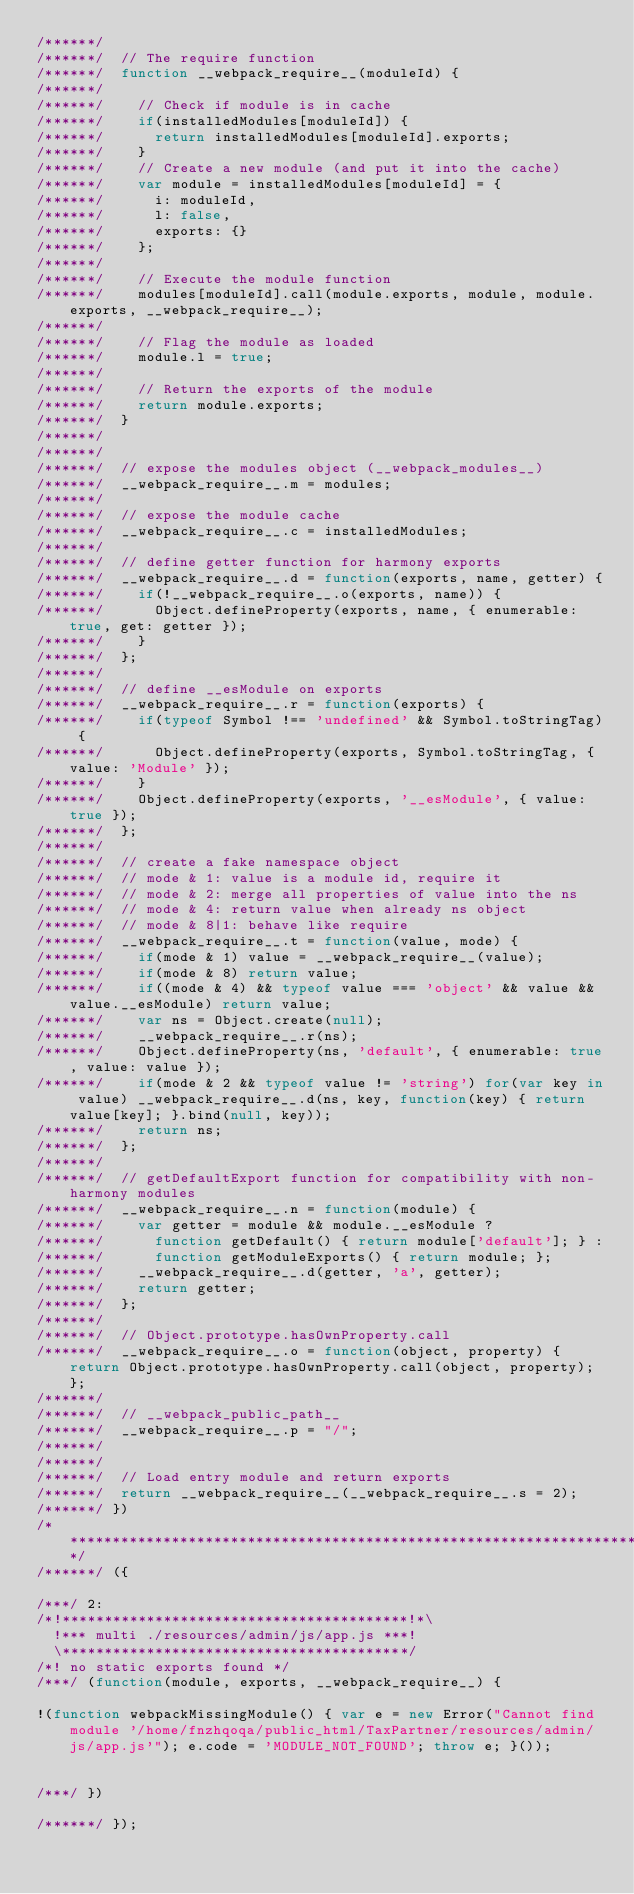<code> <loc_0><loc_0><loc_500><loc_500><_JavaScript_>/******/
/******/ 	// The require function
/******/ 	function __webpack_require__(moduleId) {
/******/
/******/ 		// Check if module is in cache
/******/ 		if(installedModules[moduleId]) {
/******/ 			return installedModules[moduleId].exports;
/******/ 		}
/******/ 		// Create a new module (and put it into the cache)
/******/ 		var module = installedModules[moduleId] = {
/******/ 			i: moduleId,
/******/ 			l: false,
/******/ 			exports: {}
/******/ 		};
/******/
/******/ 		// Execute the module function
/******/ 		modules[moduleId].call(module.exports, module, module.exports, __webpack_require__);
/******/
/******/ 		// Flag the module as loaded
/******/ 		module.l = true;
/******/
/******/ 		// Return the exports of the module
/******/ 		return module.exports;
/******/ 	}
/******/
/******/
/******/ 	// expose the modules object (__webpack_modules__)
/******/ 	__webpack_require__.m = modules;
/******/
/******/ 	// expose the module cache
/******/ 	__webpack_require__.c = installedModules;
/******/
/******/ 	// define getter function for harmony exports
/******/ 	__webpack_require__.d = function(exports, name, getter) {
/******/ 		if(!__webpack_require__.o(exports, name)) {
/******/ 			Object.defineProperty(exports, name, { enumerable: true, get: getter });
/******/ 		}
/******/ 	};
/******/
/******/ 	// define __esModule on exports
/******/ 	__webpack_require__.r = function(exports) {
/******/ 		if(typeof Symbol !== 'undefined' && Symbol.toStringTag) {
/******/ 			Object.defineProperty(exports, Symbol.toStringTag, { value: 'Module' });
/******/ 		}
/******/ 		Object.defineProperty(exports, '__esModule', { value: true });
/******/ 	};
/******/
/******/ 	// create a fake namespace object
/******/ 	// mode & 1: value is a module id, require it
/******/ 	// mode & 2: merge all properties of value into the ns
/******/ 	// mode & 4: return value when already ns object
/******/ 	// mode & 8|1: behave like require
/******/ 	__webpack_require__.t = function(value, mode) {
/******/ 		if(mode & 1) value = __webpack_require__(value);
/******/ 		if(mode & 8) return value;
/******/ 		if((mode & 4) && typeof value === 'object' && value && value.__esModule) return value;
/******/ 		var ns = Object.create(null);
/******/ 		__webpack_require__.r(ns);
/******/ 		Object.defineProperty(ns, 'default', { enumerable: true, value: value });
/******/ 		if(mode & 2 && typeof value != 'string') for(var key in value) __webpack_require__.d(ns, key, function(key) { return value[key]; }.bind(null, key));
/******/ 		return ns;
/******/ 	};
/******/
/******/ 	// getDefaultExport function for compatibility with non-harmony modules
/******/ 	__webpack_require__.n = function(module) {
/******/ 		var getter = module && module.__esModule ?
/******/ 			function getDefault() { return module['default']; } :
/******/ 			function getModuleExports() { return module; };
/******/ 		__webpack_require__.d(getter, 'a', getter);
/******/ 		return getter;
/******/ 	};
/******/
/******/ 	// Object.prototype.hasOwnProperty.call
/******/ 	__webpack_require__.o = function(object, property) { return Object.prototype.hasOwnProperty.call(object, property); };
/******/
/******/ 	// __webpack_public_path__
/******/ 	__webpack_require__.p = "/";
/******/
/******/
/******/ 	// Load entry module and return exports
/******/ 	return __webpack_require__(__webpack_require__.s = 2);
/******/ })
/************************************************************************/
/******/ ({

/***/ 2:
/*!*****************************************!*\
  !*** multi ./resources/admin/js/app.js ***!
  \*****************************************/
/*! no static exports found */
/***/ (function(module, exports, __webpack_require__) {

!(function webpackMissingModule() { var e = new Error("Cannot find module '/home/fnzhqoqa/public_html/TaxPartner/resources/admin/js/app.js'"); e.code = 'MODULE_NOT_FOUND'; throw e; }());


/***/ })

/******/ });</code> 